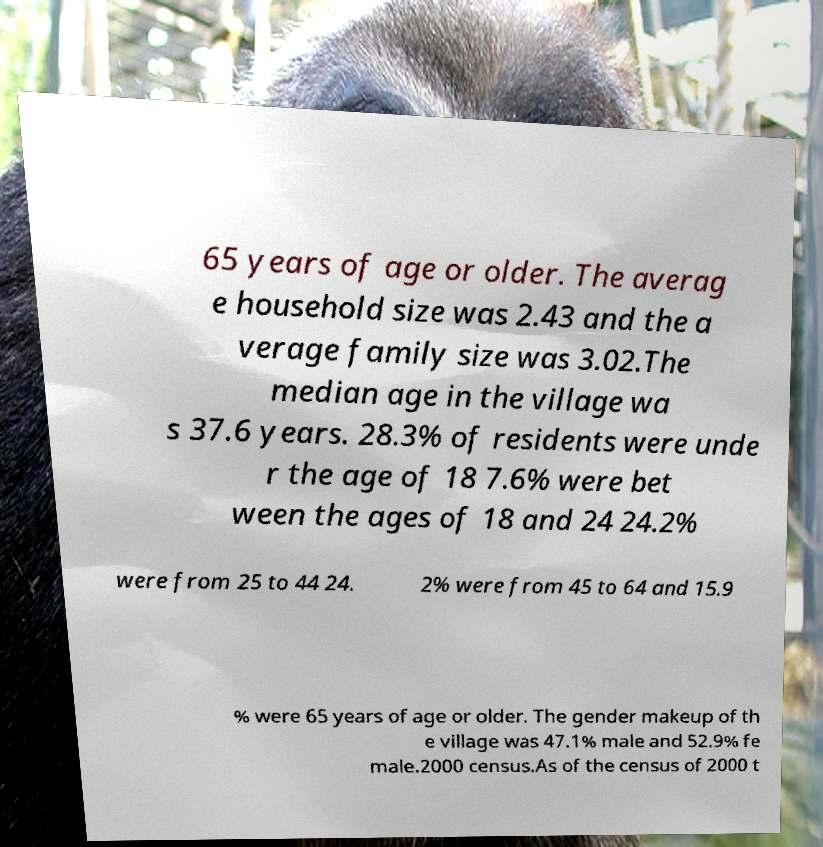There's text embedded in this image that I need extracted. Can you transcribe it verbatim? 65 years of age or older. The averag e household size was 2.43 and the a verage family size was 3.02.The median age in the village wa s 37.6 years. 28.3% of residents were unde r the age of 18 7.6% were bet ween the ages of 18 and 24 24.2% were from 25 to 44 24. 2% were from 45 to 64 and 15.9 % were 65 years of age or older. The gender makeup of th e village was 47.1% male and 52.9% fe male.2000 census.As of the census of 2000 t 